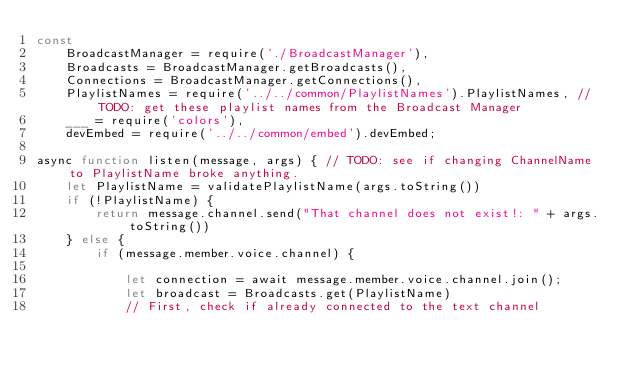<code> <loc_0><loc_0><loc_500><loc_500><_JavaScript_>const
    BroadcastManager = require('./BroadcastManager'),
    Broadcasts = BroadcastManager.getBroadcasts(),
    Connections = BroadcastManager.getConnections(),
    PlaylistNames = require('../../common/PlaylistNames').PlaylistNames, // TODO: get these playlist names from the Broadcast Manager
    ___ = require('colors'),
    devEmbed = require('../../common/embed').devEmbed;

async function listen(message, args) { // TODO: see if changing ChannelName to PlaylistName broke anything.
    let PlaylistName = validatePlaylistName(args.toString())
    if (!PlaylistName) {
        return message.channel.send("That channel does not exist!: " + args.toString())
    } else {
        if (message.member.voice.channel) {

            let connection = await message.member.voice.channel.join();
            let broadcast = Broadcasts.get(PlaylistName)
            // First, check if already connected to the text channel</code> 